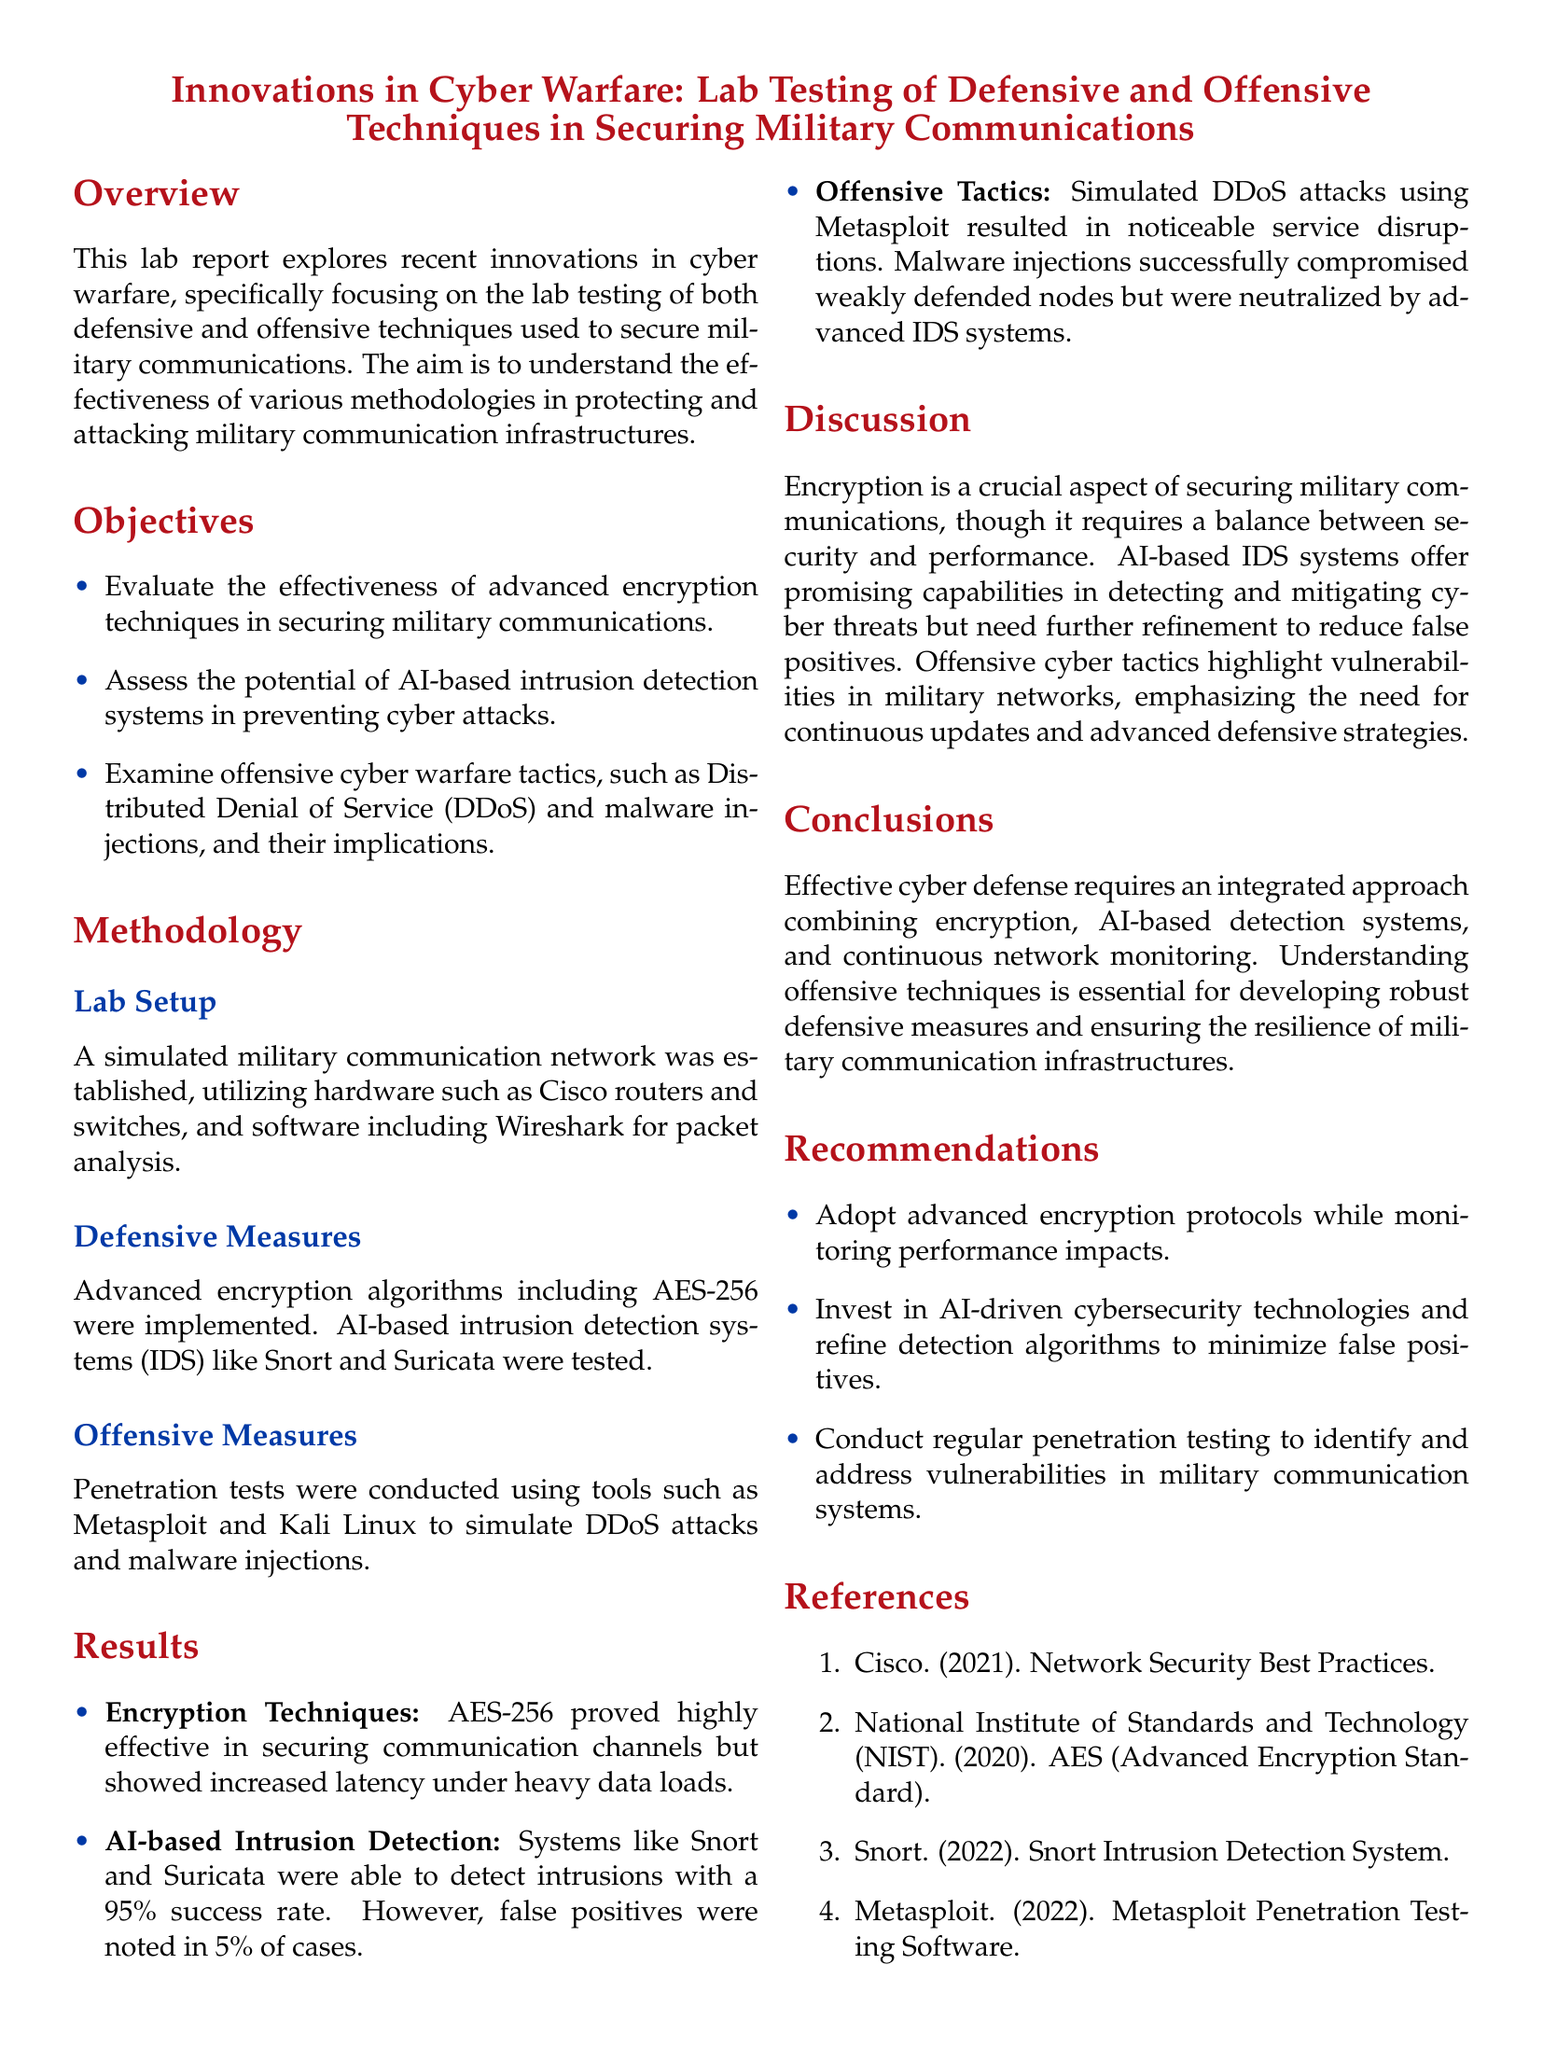What is the primary focus of the lab report? The primary focus of the lab report is to explore innovations in cyber warfare, specifically in securing military communications through defensive and offensive techniques.
Answer: innovations in cyber warfare What encryption algorithm was implemented? The document specifically mentions that AES-256 was implemented as an encryption algorithm.
Answer: AES-256 What is the detection success rate of AI-based IDS systems? The success rate of AI-based intrusion detection systems like Snort and Suricata is stated to be 95%.
Answer: 95% Which tool was used to simulate DDoS attacks? The tool used for simulating DDoS attacks in the lab setup is Metasploit.
Answer: Metasploit What are the two recommended actions for improving cybersecurity? The recommendations include adopting advanced encryption protocols and investing in AI-driven cybersecurity technologies.
Answer: advanced encryption protocols and AI-driven cybersecurity technologies What was one noted drawback of AES-256 encryption? A drawback of AES-256 encryption noted in the lab report is increased latency under heavy data loads.
Answer: increased latency How often should penetration testing be conducted according to the recommendations? The document recommends conducting regular penetration testing to maintain system security.
Answer: regularly 